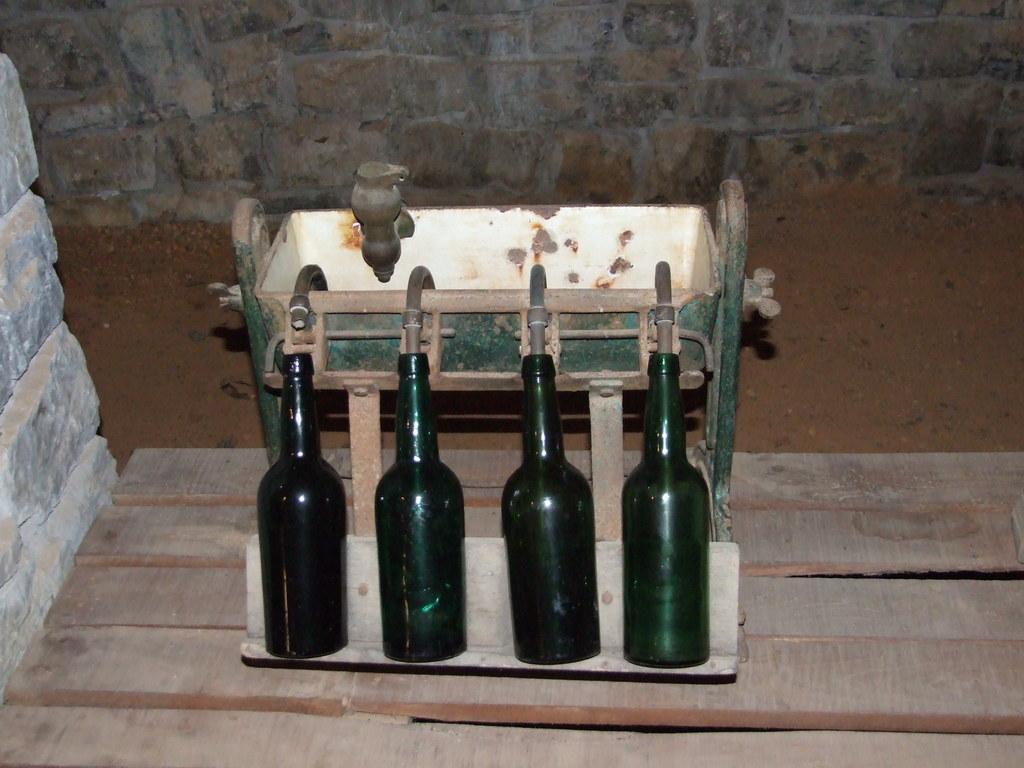In one or two sentences, can you explain what this image depicts? In this image there are four bottles to the pipes of the machine and the machine is on the table, there is a stone wall and sand. 